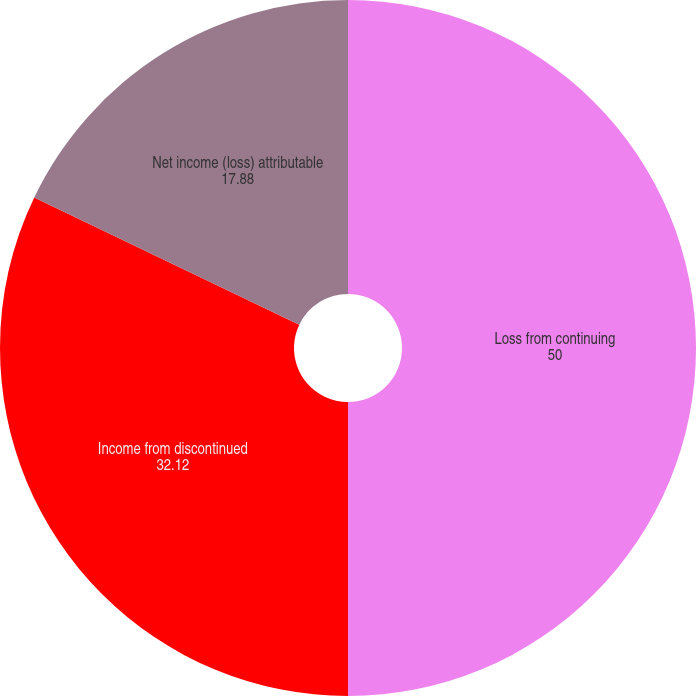Convert chart. <chart><loc_0><loc_0><loc_500><loc_500><pie_chart><fcel>Loss from continuing<fcel>Income from discontinued<fcel>Net income (loss) attributable<nl><fcel>50.0%<fcel>32.12%<fcel>17.88%<nl></chart> 